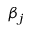Convert formula to latex. <formula><loc_0><loc_0><loc_500><loc_500>\beta _ { j }</formula> 